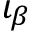Convert formula to latex. <formula><loc_0><loc_0><loc_500><loc_500>\iota _ { \beta }</formula> 